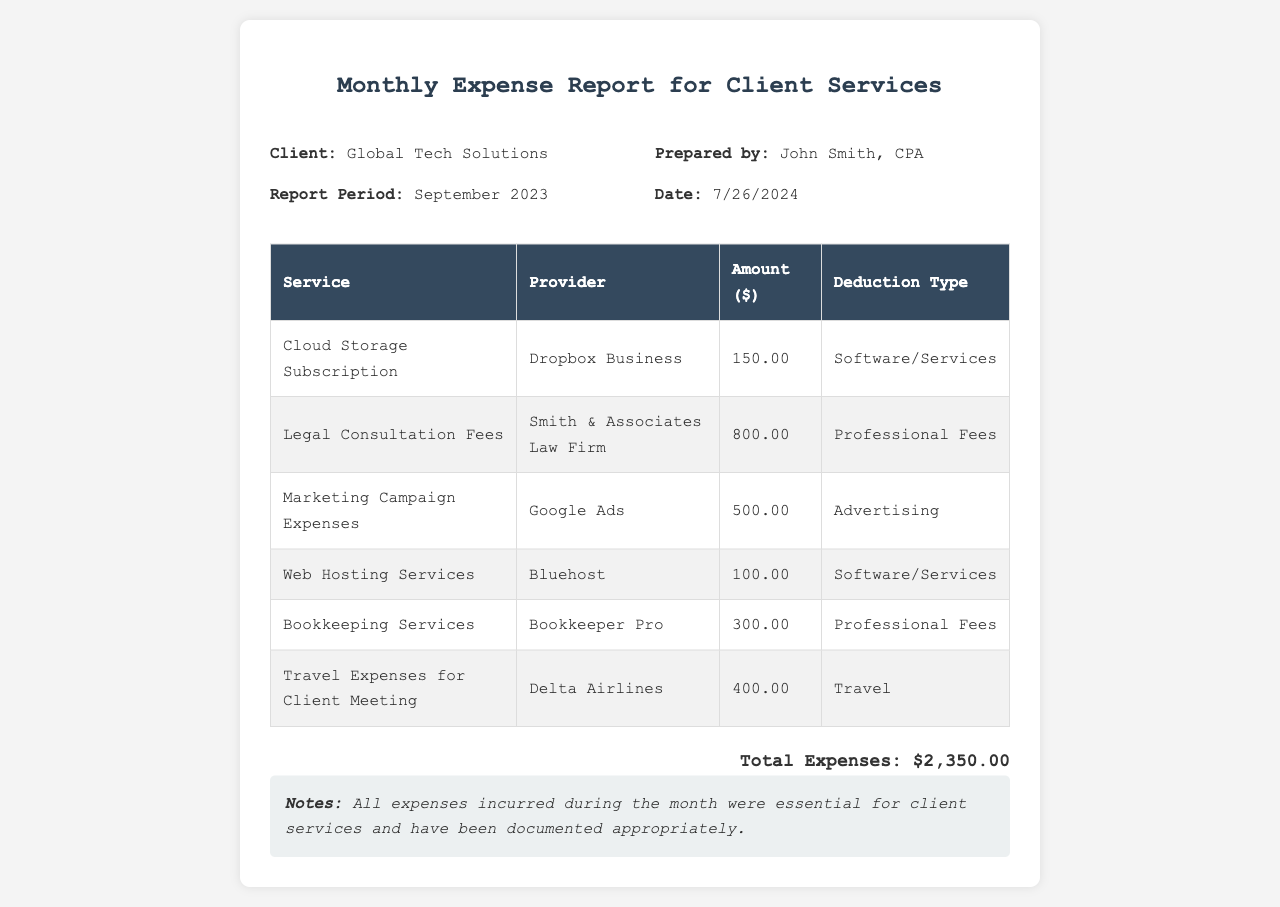what is the client name? The client's name is listed at the top of the document under "Client."
Answer: Global Tech Solutions what is the report period? The report period mentions the specific month and year at the top of the document.
Answer: September 2023 who prepared the report? The preparer's name is mentioned in the header of the document.
Answer: John Smith, CPA what is the total amount of expenses? The total expenses are summarized at the bottom of the document.
Answer: $2,350.00 how many service items are listed in the report? The number of service items can be counted from the rows in the table.
Answer: 6 what type of expense is associated with Dropbox Business? The specific deduction type is mentioned in the relevant table row.
Answer: Software/Services which provider is associated with the legal consultation fees? The provider's name is listed in the row for legal consultation fees in the table.
Answer: Smith & Associates Law Firm what is the deduction type for the travel expenses? The deduction type is mentioned in the corresponding row for travel expenses in the table.
Answer: Travel what note is provided regarding the expenses? The note details the essential nature of the expenses, which is stated in the notes section.
Answer: All expenses incurred during the month were essential for client services and have been documented appropriately 